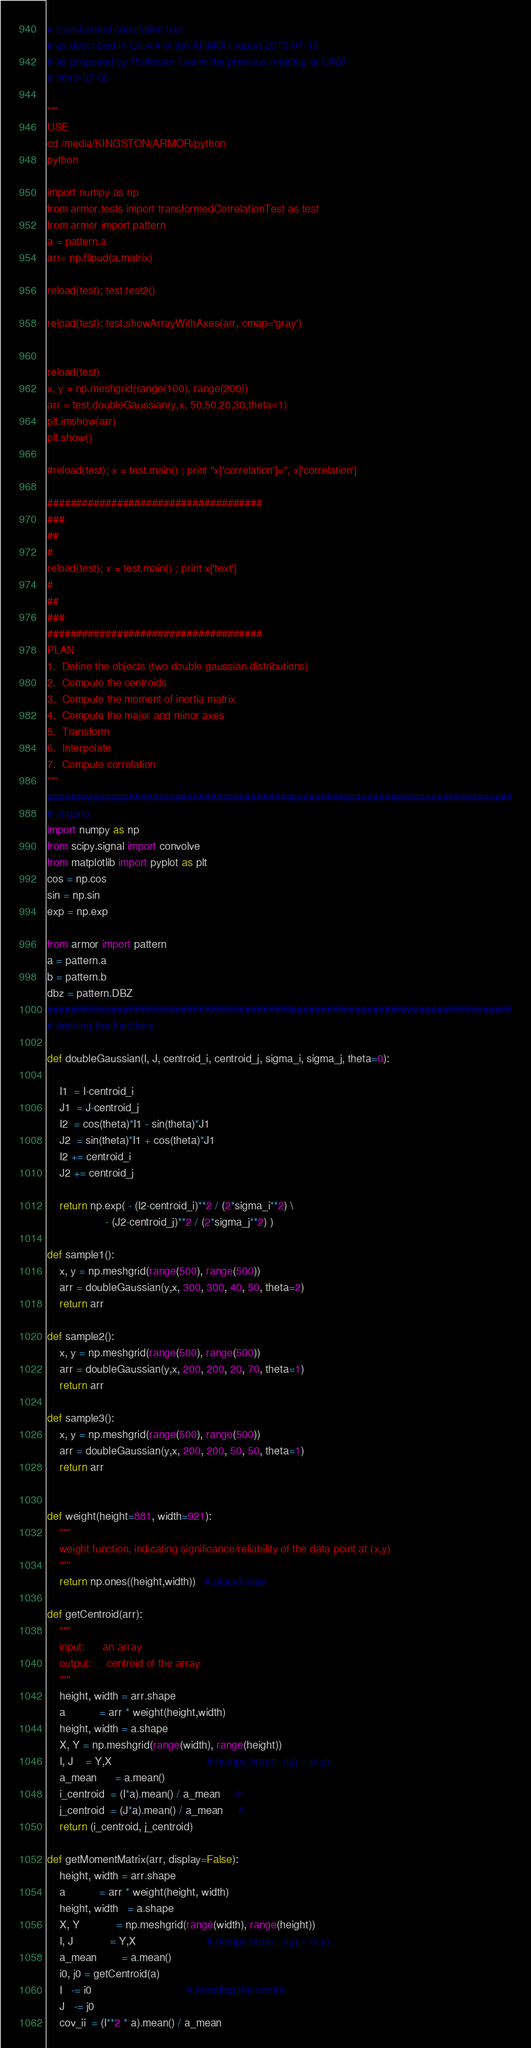Convert code to text. <code><loc_0><loc_0><loc_500><loc_500><_Python_># transformed correlation test
# as described in Ch.4.4 of the ARMOR report 2013-07-10
# as proposed by Professor Lee in the previous meeting at CWB
# 2013-07-05

"""
USE
cd /media/KINGSTON/ARMOR/python
python

import numpy as np
from armor.tests import transformedCorrelationTest as test
from armor import pattern
a = pattern.a
arr= np.flipud(a.matrix)

reload(test); test.test2()

reload(test); test.showArrayWithAxes(arr, cmap='gray')


reload(test)
x, y = np.meshgrid(range(100), range(200))
arr = test.doubleGaussian(y,x, 50,50,20,30,theta=1)
plt.imshow(arr)
plt.show()

#reload(test); x = test.main() ; print "x['correlation']=", x['correlation']

#####################################
###
##
#
reload(test); x = test.main() ; print x['text']
#
##
###
#####################################
PLAN
1.  Define the objects (two double gaussian distributions)
2.  Compute the centroids
3.  Compute the moment of inertia matrix
4.  Compute the major and minor axes
5.  Transform
6.  Interpolate
7.  Compute correlation
"""
################################################################################
# imports
import numpy as np
from scipy.signal import convolve
from matplotlib import pyplot as plt
cos = np.cos
sin = np.sin
exp = np.exp

from armor import pattern
a = pattern.a
b = pattern.b
dbz = pattern.DBZ
################################################################################
# defining the functions

def doubleGaussian(I, J, centroid_i, centroid_j, sigma_i, sigma_j, theta=0):

    I1  = I-centroid_i
    J1  = J-centroid_j
    I2  = cos(theta)*I1 - sin(theta)*J1
    J2  = sin(theta)*I1 + cos(theta)*J1
    I2 += centroid_i
    J2 += centroid_j

    return np.exp( - (I2-centroid_i)**2 / (2*sigma_i**2) \
                   - (J2-centroid_j)**2 / (2*sigma_j**2) )

def sample1():
    x, y = np.meshgrid(range(500), range(500))
    arr = doubleGaussian(y,x, 300, 300, 40, 50, theta=2)
    return arr

def sample2():
    x, y = np.meshgrid(range(500), range(500))
    arr = doubleGaussian(y,x, 200, 200, 20, 70, theta=1)
    return arr

def sample3():
    x, y = np.meshgrid(range(500), range(500))
    arr = doubleGaussian(y,x, 200, 200, 50, 50, theta=1)
    return arr


def weight(height=881, width=921):
    """
    weight function, indicating significance/reliability of the data point at (x,y)
    """
    return np.ones((height,width))   # placeholder

def getCentroid(arr):
    """
    input:      an array
    output:     centroid of the array
    """
    height, width = arr.shape
    a           = arr * weight(height,width)
    height, width = a.shape
    X, Y = np.meshgrid(range(width), range(height))
    I, J    = Y,X                               # numpy order:  (i,j) = (x,y)
    a_mean      = a.mean()
    i_centroid  = (I*a).mean() / a_mean     #
    j_centroid  = (J*a).mean() / a_mean     # 
    return (i_centroid, j_centroid)

def getMomentMatrix(arr, display=False):
    height, width = arr.shape
    a           = arr * weight(height, width)
    height, width   = a.shape
    X, Y            = np.meshgrid(range(width), range(height))
    I, J            = Y,X                       # numpy order:  (i,j) = (x,y)
    a_mean        = a.mean()
    i0, j0 = getCentroid(a)
    I   -= i0                               # resetting the centre
    J   -= j0
    cov_ii  = (I**2 * a).mean() / a_mean</code> 